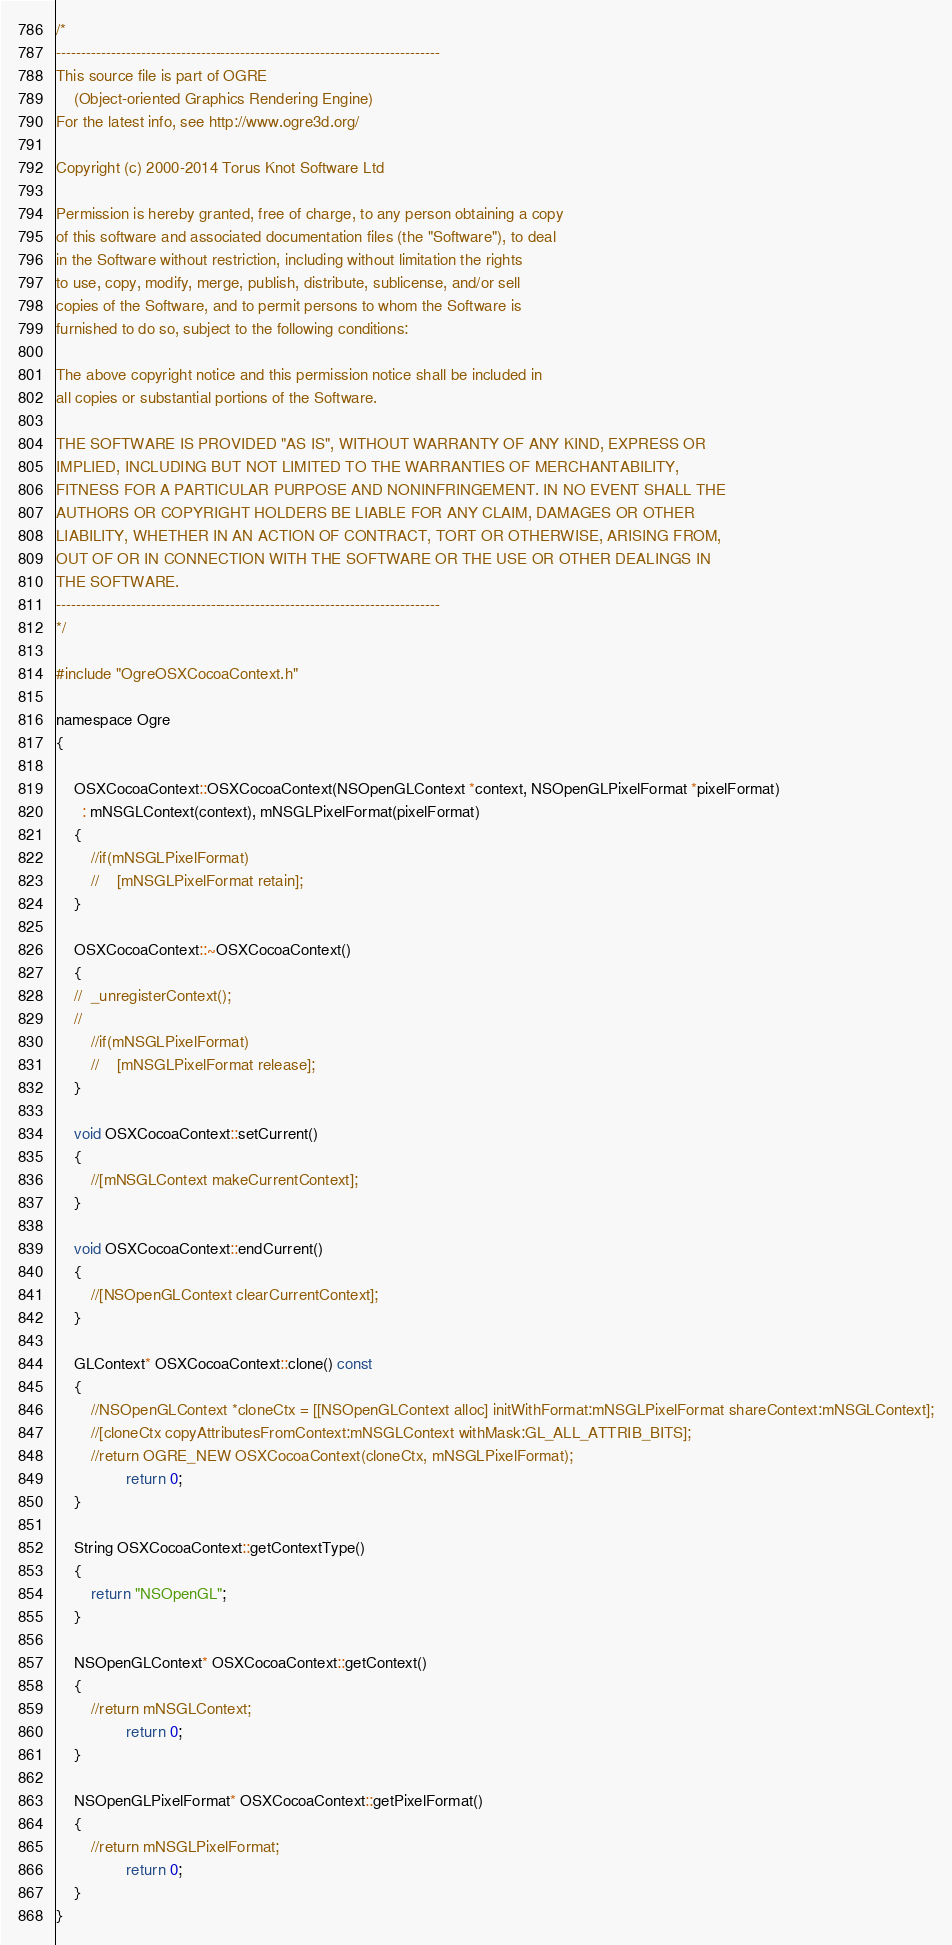Convert code to text. <code><loc_0><loc_0><loc_500><loc_500><_ObjectiveC_>/*
-----------------------------------------------------------------------------
This source file is part of OGRE
    (Object-oriented Graphics Rendering Engine)
For the latest info, see http://www.ogre3d.org/

Copyright (c) 2000-2014 Torus Knot Software Ltd

Permission is hereby granted, free of charge, to any person obtaining a copy
of this software and associated documentation files (the "Software"), to deal
in the Software without restriction, including without limitation the rights
to use, copy, modify, merge, publish, distribute, sublicense, and/or sell
copies of the Software, and to permit persons to whom the Software is
furnished to do so, subject to the following conditions:

The above copyright notice and this permission notice shall be included in
all copies or substantial portions of the Software.

THE SOFTWARE IS PROVIDED "AS IS", WITHOUT WARRANTY OF ANY KIND, EXPRESS OR
IMPLIED, INCLUDING BUT NOT LIMITED TO THE WARRANTIES OF MERCHANTABILITY,
FITNESS FOR A PARTICULAR PURPOSE AND NONINFRINGEMENT. IN NO EVENT SHALL THE
AUTHORS OR COPYRIGHT HOLDERS BE LIABLE FOR ANY CLAIM, DAMAGES OR OTHER
LIABILITY, WHETHER IN AN ACTION OF CONTRACT, TORT OR OTHERWISE, ARISING FROM,
OUT OF OR IN CONNECTION WITH THE SOFTWARE OR THE USE OR OTHER DEALINGS IN
THE SOFTWARE.
-----------------------------------------------------------------------------
*/

#include "OgreOSXCocoaContext.h"

namespace Ogre
{

    OSXCocoaContext::OSXCocoaContext(NSOpenGLContext *context, NSOpenGLPixelFormat *pixelFormat)
      : mNSGLContext(context), mNSGLPixelFormat(pixelFormat)
	{
        //if(mNSGLPixelFormat)
        //    [mNSGLPixelFormat retain];
	}
	    
	OSXCocoaContext::~OSXCocoaContext()
	{
	//	_unregisterContext();
	//	
        //if(mNSGLPixelFormat)
        //    [mNSGLPixelFormat release];
    }

    void OSXCocoaContext::setCurrent()
	{
		//[mNSGLContext makeCurrentContext];
    }
		
	void OSXCocoaContext::endCurrent()
	{
        //[NSOpenGLContext clearCurrentContext]; 
	}
	
	GLContext* OSXCocoaContext::clone() const
	{
		//NSOpenGLContext *cloneCtx = [[NSOpenGLContext alloc] initWithFormat:mNSGLPixelFormat shareContext:mNSGLContext];
		//[cloneCtx copyAttributesFromContext:mNSGLContext withMask:GL_ALL_ATTRIB_BITS];
		//return OGRE_NEW OSXCocoaContext(cloneCtx, mNSGLPixelFormat);
                return 0;
	}
	
	String OSXCocoaContext::getContextType()
	{
		return "NSOpenGL";
	}
	
	NSOpenGLContext* OSXCocoaContext::getContext()
	{
		//return mNSGLContext;
                return 0;
    }
  
	NSOpenGLPixelFormat* OSXCocoaContext::getPixelFormat()
	{
		//return mNSGLPixelFormat;
                return 0;
	}
}
</code> 